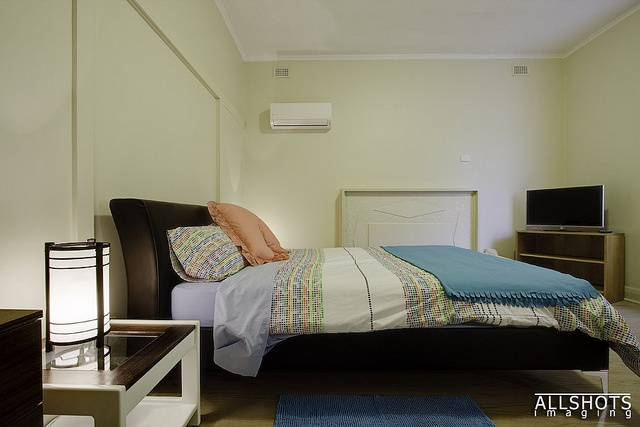Describe the objects in this image and their specific colors. I can see bed in darkgray, gray, and tan tones and tv in darkgray, black, gray, and darkgreen tones in this image. 